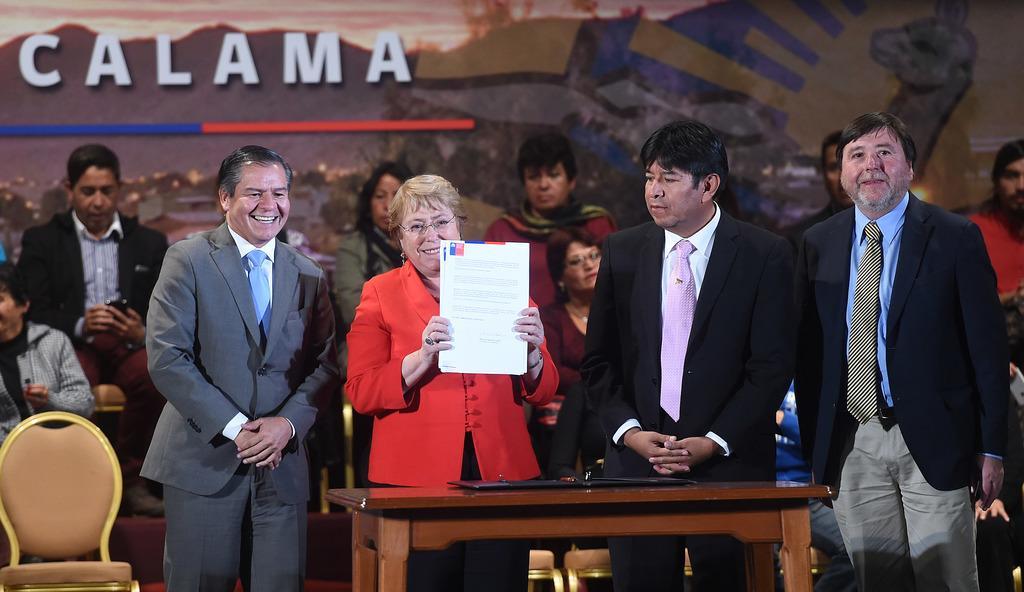Please provide a concise description of this image. In this image I can see a woman wearing red color dress is standing and holding few papers in her hand. I can see a chair,a table and few persons standing beside her. In the background I can see few persons sitting and a huge banner in which I can see few mountains, few lights, few buildings, few trees and the sky. 